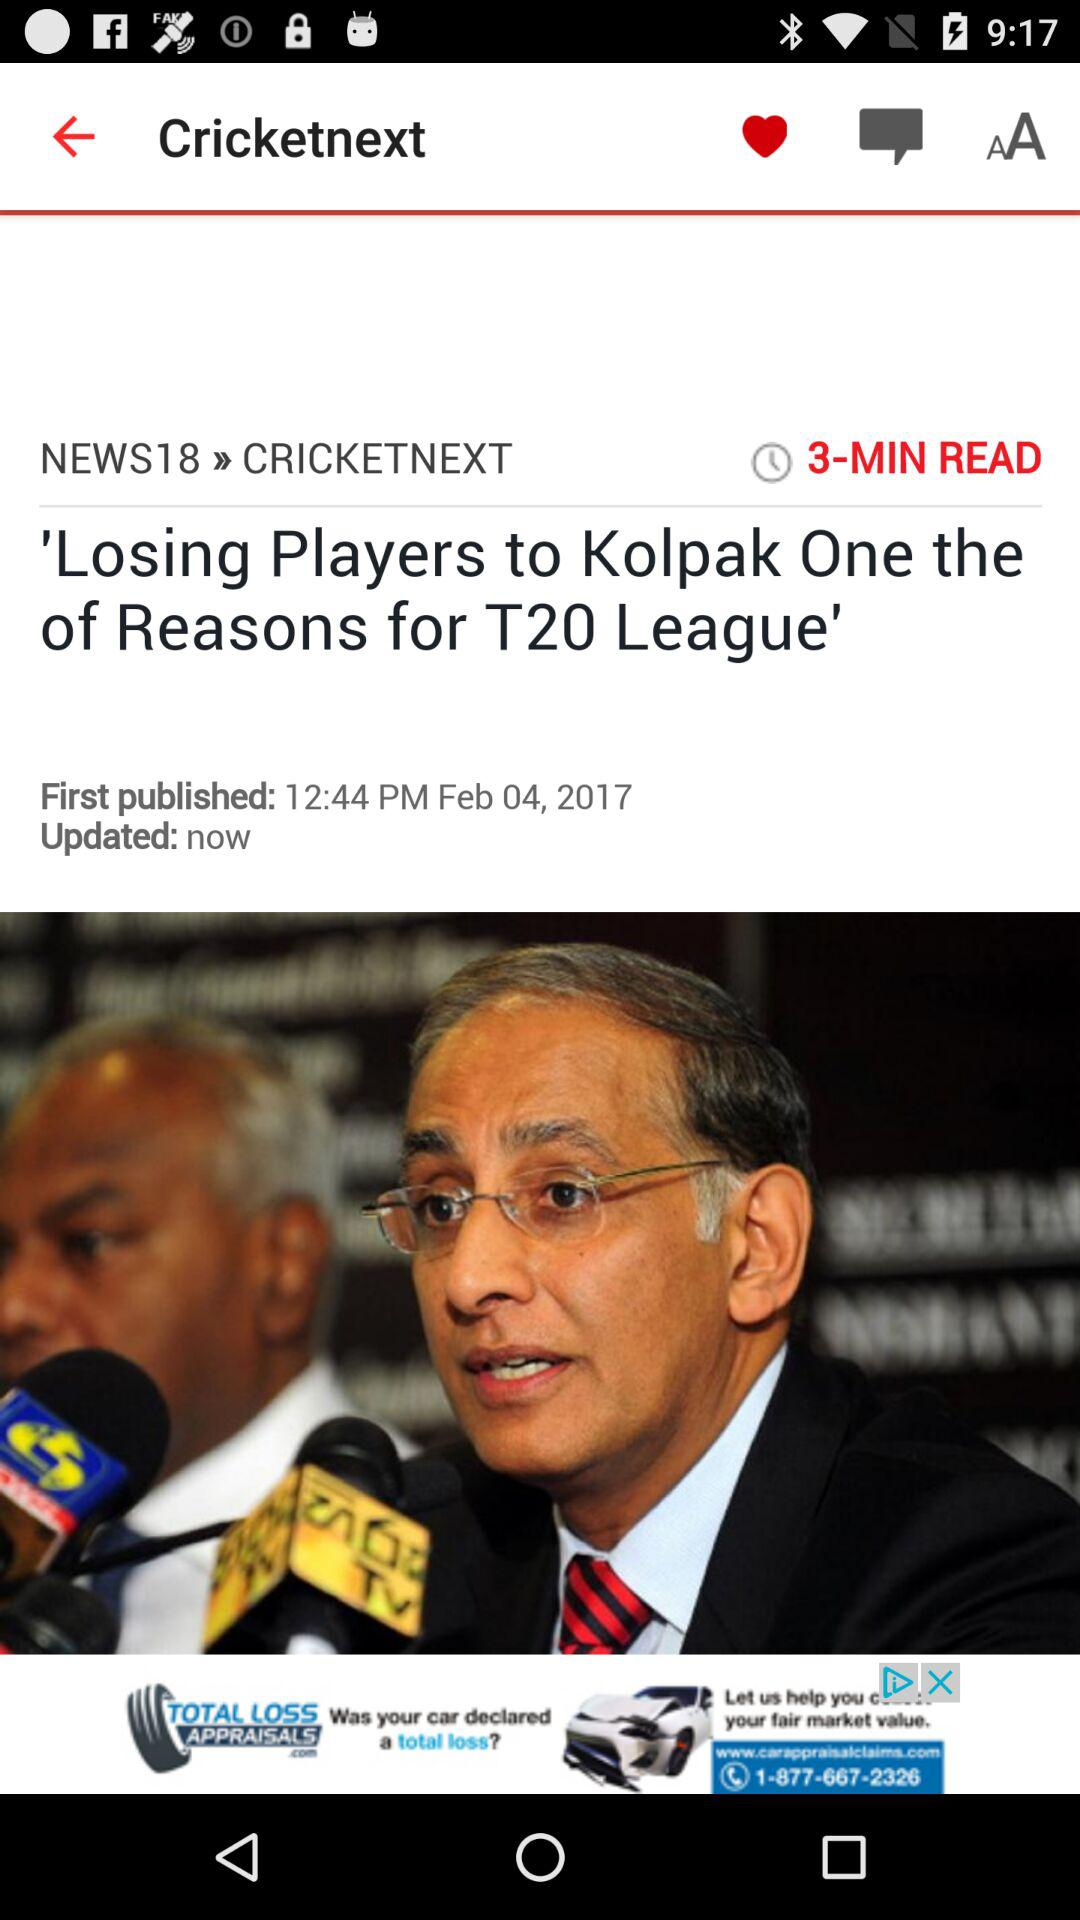What is the headline of the news? The headline of the news is "'Losing Players to Kolpak One the of Reasons for T20 League'". 